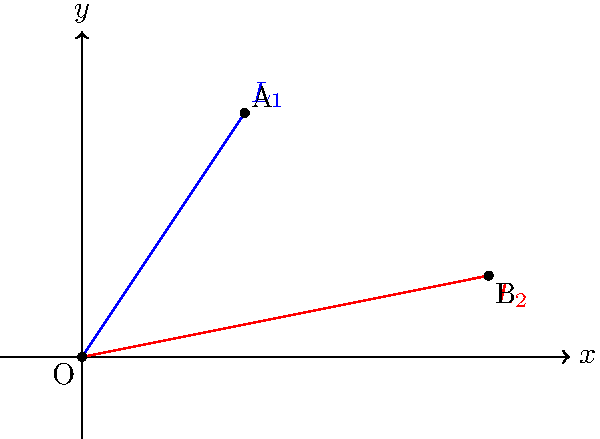Imagine you're setting up the stage for Post Malone's concert. Two spotlights need to be adjusted, represented by lines $L_1$ and $L_2$ in the coordinate system. $L_1$ passes through points O(0,0) and A(2,3), while $L_2$ passes through points O(0,0) and B(5,1). Calculate the angle between these two spotlights to ensure optimal lighting for the performance. To find the angle between the two lines, we'll follow these steps:

1) First, we need to find the slopes of both lines:

   For $L_1$: $m_1 = \frac{y_2 - y_1}{x_2 - x_1} = \frac{3 - 0}{2 - 0} = \frac{3}{2}$

   For $L_2$: $m_2 = \frac{y_2 - y_1}{x_2 - x_1} = \frac{1 - 0}{5 - 0} = \frac{1}{5}$

2) Now, we can use the formula for the angle between two lines:

   $\tan \theta = |\frac{m_2 - m_1}{1 + m_1m_2}|$

3) Substituting our values:

   $\tan \theta = |\frac{\frac{1}{5} - \frac{3}{2}}{1 + \frac{3}{2} \cdot \frac{1}{5}}|$

4) Simplify:
   
   $\tan \theta = |\frac{\frac{2}{10} - \frac{15}{10}}{1 + \frac{3}{10}}| = |\frac{-\frac{13}{10}}{\frac{13}{10}}| = 1$

5) Now, we need to find the angle whose tangent is 1:

   $\theta = \arctan(1) = 45°$

Therefore, the angle between the two spotlights is 45°.
Answer: 45° 